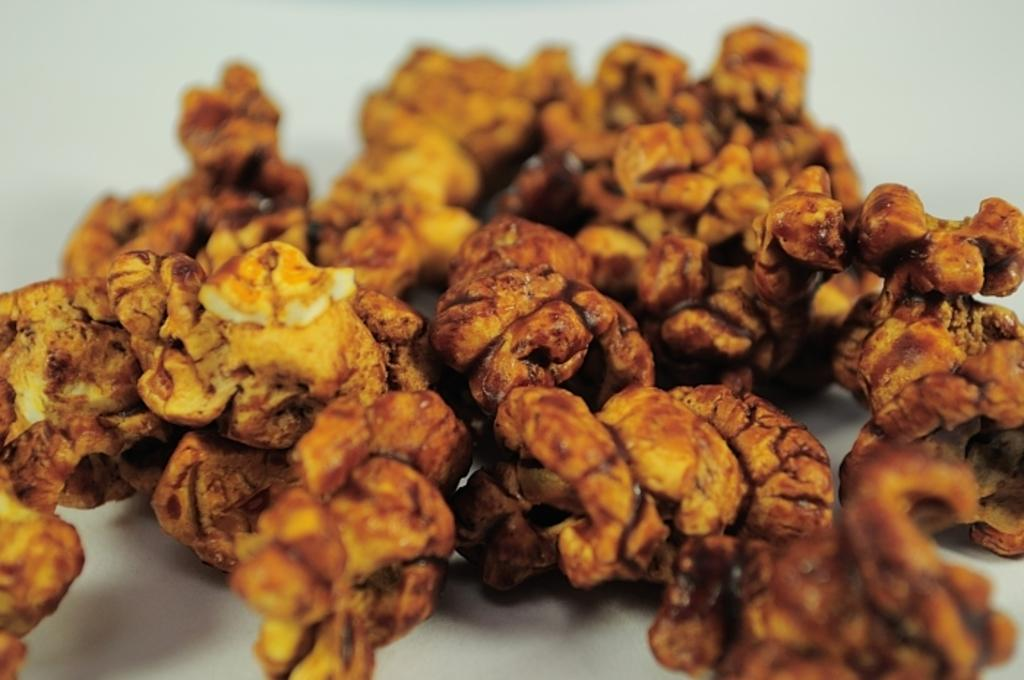What is the main subject of the image? The main subject of the image is food placed on a white surface. Can you describe the background of the image? The backdrop of the image is blurred. How does the food stretch in the image? The food does not stretch in the image; it is stationary on the white surface. 